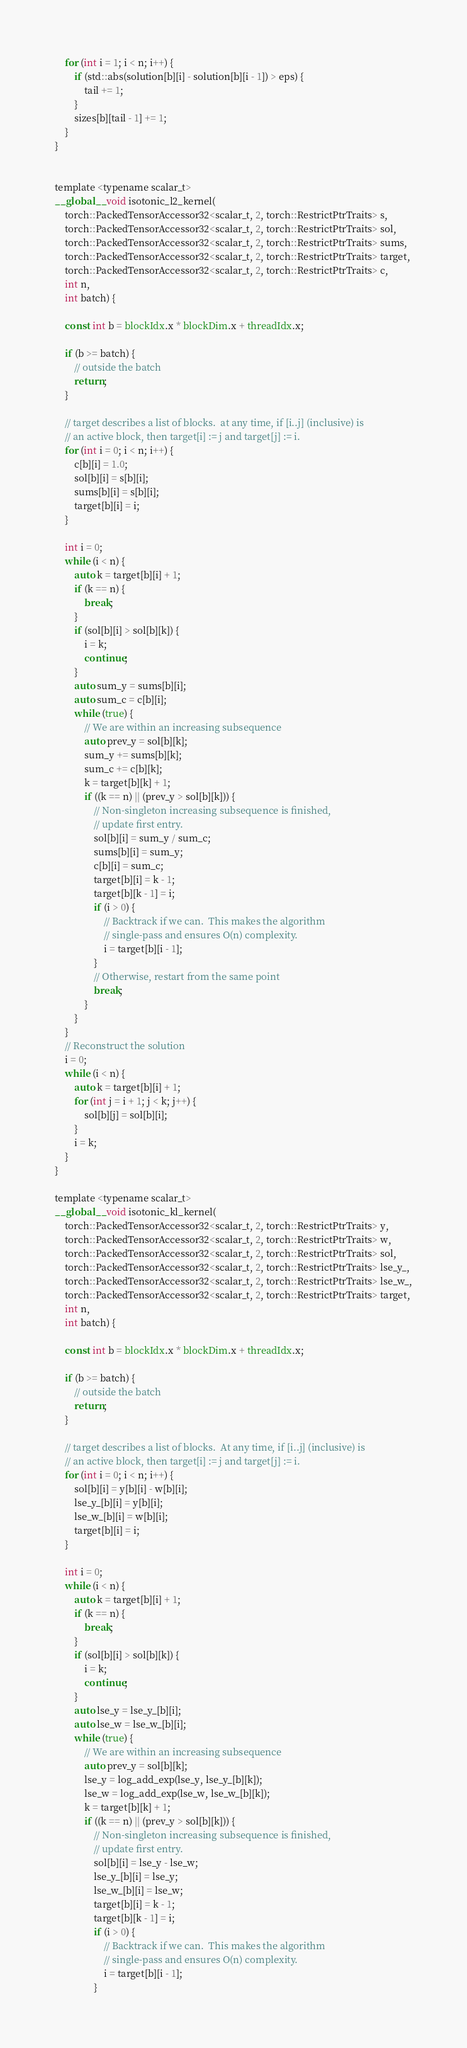Convert code to text. <code><loc_0><loc_0><loc_500><loc_500><_Cuda_>
    for (int i = 1; i < n; i++) {
        if (std::abs(solution[b][i] - solution[b][i - 1]) > eps) {
            tail += 1; 
        }
        sizes[b][tail - 1] += 1;
    }
}


template <typename scalar_t>
__global__ void isotonic_l2_kernel(
    torch::PackedTensorAccessor32<scalar_t, 2, torch::RestrictPtrTraits> s,
    torch::PackedTensorAccessor32<scalar_t, 2, torch::RestrictPtrTraits> sol,
    torch::PackedTensorAccessor32<scalar_t, 2, torch::RestrictPtrTraits> sums,
    torch::PackedTensorAccessor32<scalar_t, 2, torch::RestrictPtrTraits> target,
    torch::PackedTensorAccessor32<scalar_t, 2, torch::RestrictPtrTraits> c,
    int n,
    int batch) {

    const int b = blockIdx.x * blockDim.x + threadIdx.x;

    if (b >= batch) {
        // outside the batch
        return;
    }

    // target describes a list of blocks.  at any time, if [i..j] (inclusive) is
    // an active block, then target[i] := j and target[j] := i.
    for (int i = 0; i < n; i++) {
        c[b][i] = 1.0;
        sol[b][i] = s[b][i];
        sums[b][i] = s[b][i];
        target[b][i] = i;
    }

    int i = 0;
    while (i < n) {
        auto k = target[b][i] + 1;
        if (k == n) {
            break;
        }
        if (sol[b][i] > sol[b][k]) {
            i = k;
            continue;
        }
        auto sum_y = sums[b][i];
        auto sum_c = c[b][i];
        while (true) {
            // We are within an increasing subsequence
            auto prev_y = sol[b][k];
            sum_y += sums[b][k];
            sum_c += c[b][k];
            k = target[b][k] + 1;
            if ((k == n) || (prev_y > sol[b][k])) {
                // Non-singleton increasing subsequence is finished,
                // update first entry.
                sol[b][i] = sum_y / sum_c;
                sums[b][i] = sum_y;
                c[b][i] = sum_c;
                target[b][i] = k - 1;
                target[b][k - 1] = i;
                if (i > 0) {
                    // Backtrack if we can.  This makes the algorithm
                    // single-pass and ensures O(n) complexity.
                    i = target[b][i - 1];
                }
                // Otherwise, restart from the same point
                break;
            }
        }
    }
    // Reconstruct the solution
    i = 0;
    while (i < n) {
        auto k = target[b][i] + 1;
        for (int j = i + 1; j < k; j++) {
            sol[b][j] = sol[b][i];
        }
        i = k;
    }
}

template <typename scalar_t>
__global__ void isotonic_kl_kernel(
    torch::PackedTensorAccessor32<scalar_t, 2, torch::RestrictPtrTraits> y,
    torch::PackedTensorAccessor32<scalar_t, 2, torch::RestrictPtrTraits> w,
    torch::PackedTensorAccessor32<scalar_t, 2, torch::RestrictPtrTraits> sol,
    torch::PackedTensorAccessor32<scalar_t, 2, torch::RestrictPtrTraits> lse_y_,
    torch::PackedTensorAccessor32<scalar_t, 2, torch::RestrictPtrTraits> lse_w_,
    torch::PackedTensorAccessor32<scalar_t, 2, torch::RestrictPtrTraits> target,
    int n,
    int batch) {

    const int b = blockIdx.x * blockDim.x + threadIdx.x;

    if (b >= batch) {
        // outside the batch
        return;
    }

    // target describes a list of blocks.  At any time, if [i..j] (inclusive) is
    // an active block, then target[i] := j and target[j] := i.
    for (int i = 0; i < n; i++) {
        sol[b][i] = y[b][i] - w[b][i];
        lse_y_[b][i] = y[b][i];
        lse_w_[b][i] = w[b][i];
        target[b][i] = i;
    }

    int i = 0;
    while (i < n) {
        auto k = target[b][i] + 1;
        if (k == n) {
            break;
        }
        if (sol[b][i] > sol[b][k]) {
            i = k;
            continue;
        }
        auto lse_y = lse_y_[b][i];
        auto lse_w = lse_w_[b][i];
        while (true) {
            // We are within an increasing subsequence
            auto prev_y = sol[b][k];
            lse_y = log_add_exp(lse_y, lse_y_[b][k]);
            lse_w = log_add_exp(lse_w, lse_w_[b][k]);
            k = target[b][k] + 1;
            if ((k == n) || (prev_y > sol[b][k])) {
                // Non-singleton increasing subsequence is finished,
                // update first entry.
                sol[b][i] = lse_y - lse_w;
                lse_y_[b][i] = lse_y;
                lse_w_[b][i] = lse_w;
                target[b][i] = k - 1;
                target[b][k - 1] = i;
                if (i > 0) {
                    // Backtrack if we can.  This makes the algorithm
                    // single-pass and ensures O(n) complexity.
                    i = target[b][i - 1];
                }</code> 